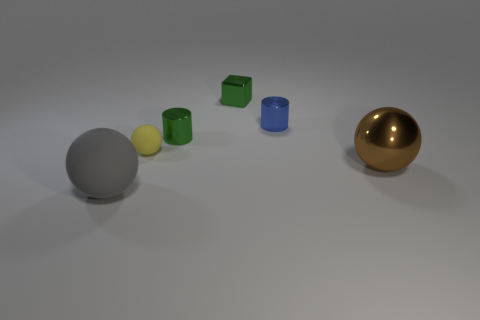Add 4 tiny blue metal objects. How many objects exist? 10 Subtract all cylinders. How many objects are left? 4 Subtract all yellow balls. Subtract all green metal cylinders. How many objects are left? 4 Add 4 tiny green metal cubes. How many tiny green metal cubes are left? 5 Add 2 yellow balls. How many yellow balls exist? 3 Subtract 1 brown spheres. How many objects are left? 5 